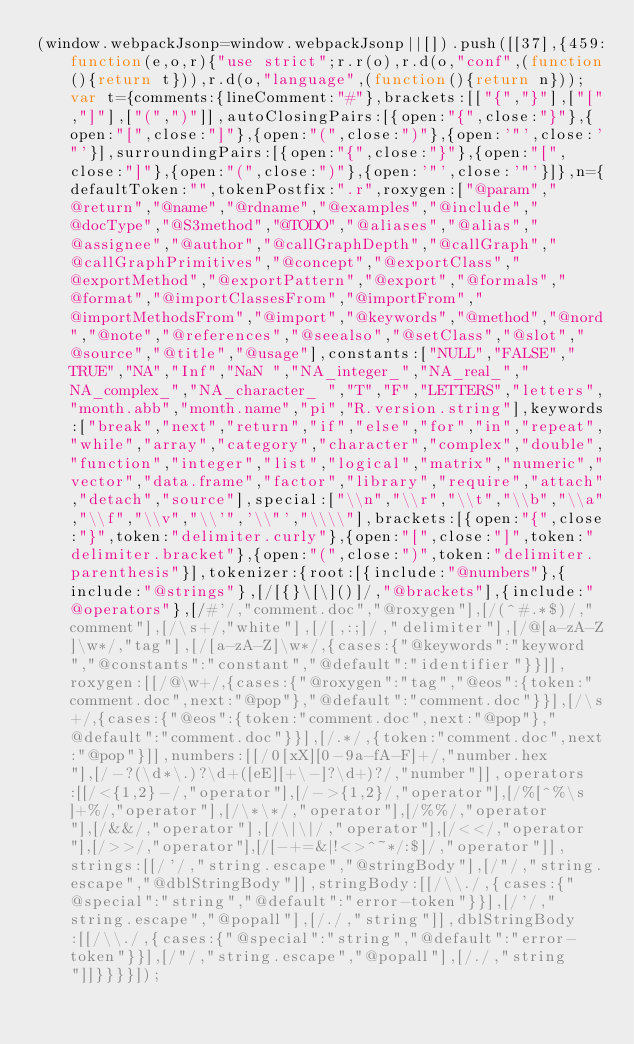<code> <loc_0><loc_0><loc_500><loc_500><_JavaScript_>(window.webpackJsonp=window.webpackJsonp||[]).push([[37],{459:function(e,o,r){"use strict";r.r(o),r.d(o,"conf",(function(){return t})),r.d(o,"language",(function(){return n}));var t={comments:{lineComment:"#"},brackets:[["{","}"],["[","]"],["(",")"]],autoClosingPairs:[{open:"{",close:"}"},{open:"[",close:"]"},{open:"(",close:")"},{open:'"',close:'"'}],surroundingPairs:[{open:"{",close:"}"},{open:"[",close:"]"},{open:"(",close:")"},{open:'"',close:'"'}]},n={defaultToken:"",tokenPostfix:".r",roxygen:["@param","@return","@name","@rdname","@examples","@include","@docType","@S3method","@TODO","@aliases","@alias","@assignee","@author","@callGraphDepth","@callGraph","@callGraphPrimitives","@concept","@exportClass","@exportMethod","@exportPattern","@export","@formals","@format","@importClassesFrom","@importFrom","@importMethodsFrom","@import","@keywords","@method","@nord","@note","@references","@seealso","@setClass","@slot","@source","@title","@usage"],constants:["NULL","FALSE","TRUE","NA","Inf","NaN ","NA_integer_","NA_real_","NA_complex_","NA_character_ ","T","F","LETTERS","letters","month.abb","month.name","pi","R.version.string"],keywords:["break","next","return","if","else","for","in","repeat","while","array","category","character","complex","double","function","integer","list","logical","matrix","numeric","vector","data.frame","factor","library","require","attach","detach","source"],special:["\\n","\\r","\\t","\\b","\\a","\\f","\\v","\\'",'\\"',"\\\\"],brackets:[{open:"{",close:"}",token:"delimiter.curly"},{open:"[",close:"]",token:"delimiter.bracket"},{open:"(",close:")",token:"delimiter.parenthesis"}],tokenizer:{root:[{include:"@numbers"},{include:"@strings"},[/[{}\[\]()]/,"@brackets"],{include:"@operators"},[/#'/,"comment.doc","@roxygen"],[/(^#.*$)/,"comment"],[/\s+/,"white"],[/[,:;]/,"delimiter"],[/@[a-zA-Z]\w*/,"tag"],[/[a-zA-Z]\w*/,{cases:{"@keywords":"keyword","@constants":"constant","@default":"identifier"}}]],roxygen:[[/@\w+/,{cases:{"@roxygen":"tag","@eos":{token:"comment.doc",next:"@pop"},"@default":"comment.doc"}}],[/\s+/,{cases:{"@eos":{token:"comment.doc",next:"@pop"},"@default":"comment.doc"}}],[/.*/,{token:"comment.doc",next:"@pop"}]],numbers:[[/0[xX][0-9a-fA-F]+/,"number.hex"],[/-?(\d*\.)?\d+([eE][+\-]?\d+)?/,"number"]],operators:[[/<{1,2}-/,"operator"],[/->{1,2}/,"operator"],[/%[^%\s]+%/,"operator"],[/\*\*/,"operator"],[/%%/,"operator"],[/&&/,"operator"],[/\|\|/,"operator"],[/<</,"operator"],[/>>/,"operator"],[/[-+=&|!<>^~*/:$]/,"operator"]],strings:[[/'/,"string.escape","@stringBody"],[/"/,"string.escape","@dblStringBody"]],stringBody:[[/\\./,{cases:{"@special":"string","@default":"error-token"}}],[/'/,"string.escape","@popall"],[/./,"string"]],dblStringBody:[[/\\./,{cases:{"@special":"string","@default":"error-token"}}],[/"/,"string.escape","@popall"],[/./,"string"]]}}}}]);</code> 